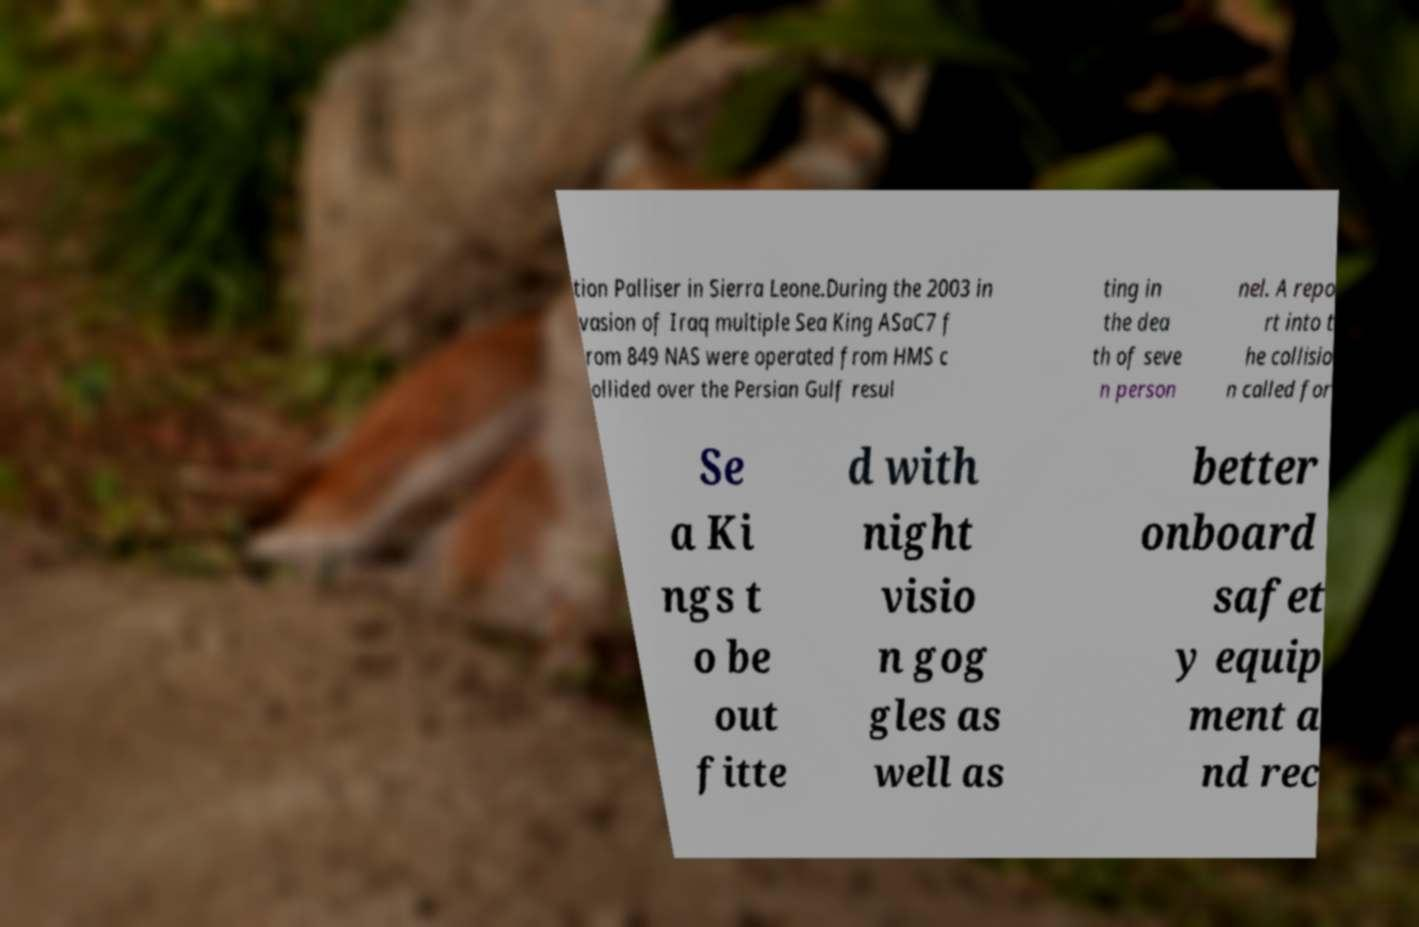Can you accurately transcribe the text from the provided image for me? tion Palliser in Sierra Leone.During the 2003 in vasion of Iraq multiple Sea King ASaC7 f rom 849 NAS were operated from HMS c ollided over the Persian Gulf resul ting in the dea th of seve n person nel. A repo rt into t he collisio n called for Se a Ki ngs t o be out fitte d with night visio n gog gles as well as better onboard safet y equip ment a nd rec 